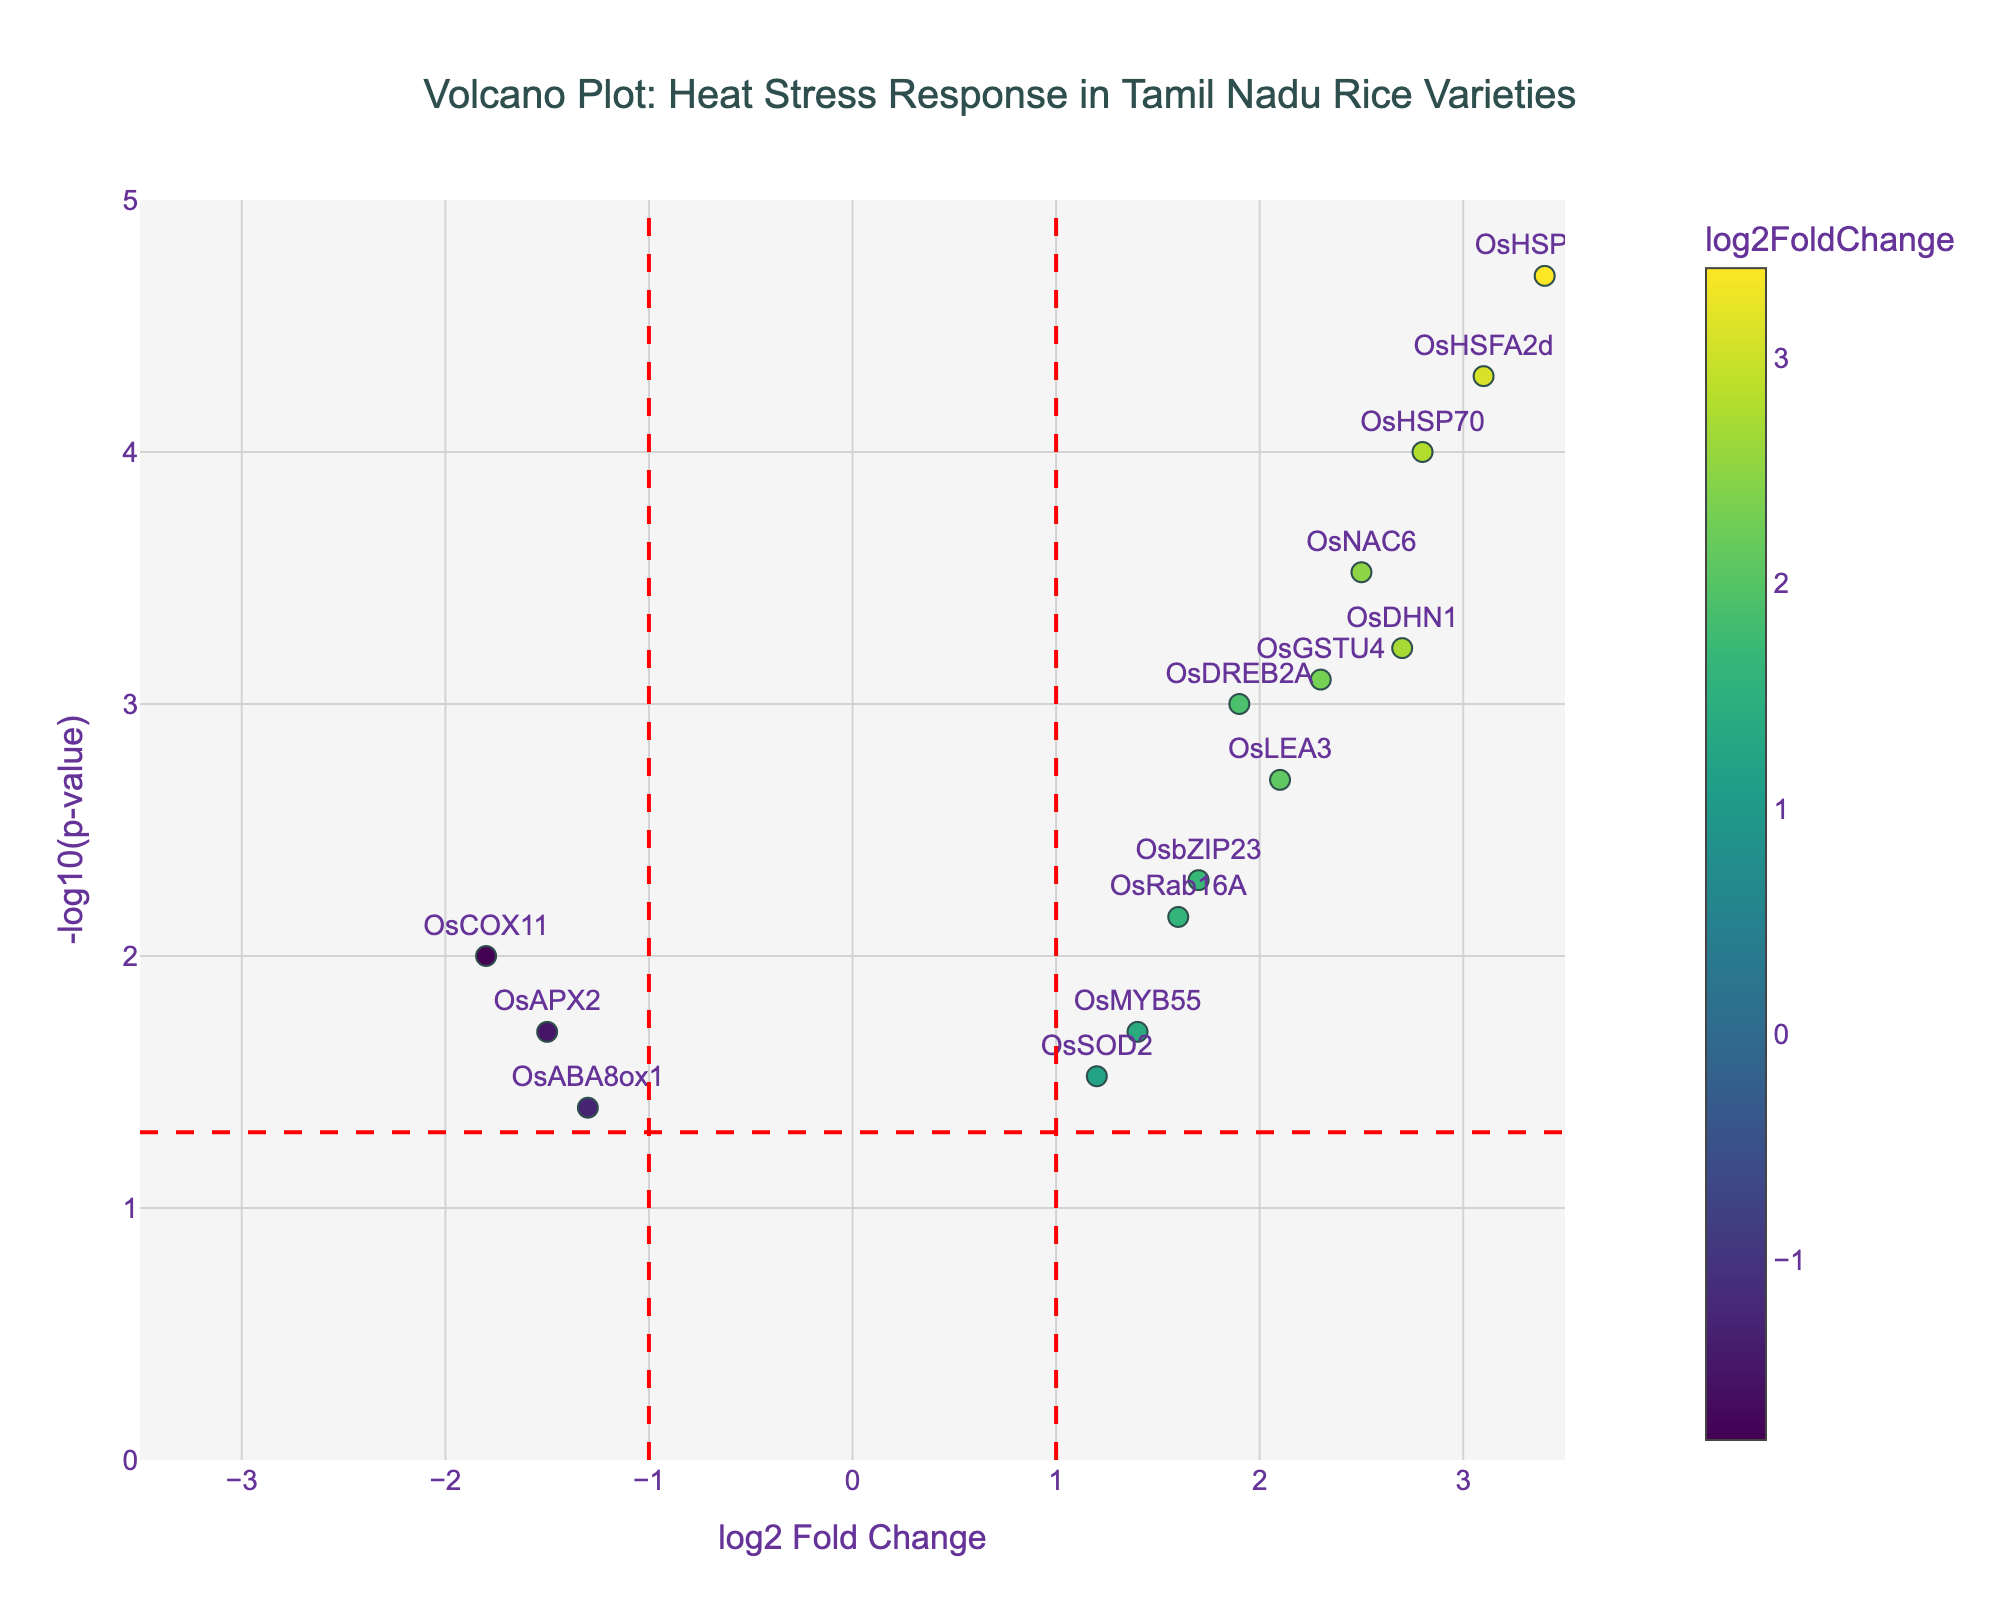What's the title of the figure? The title is generally placed at the top center of the figure. It provides an idea of what the figure represents. In this case, it reads "Volcano Plot: Heat Stress Response in Tamil Nadu Rice Varieties".
Answer: Volcano Plot: Heat Stress Response in Tamil Nadu Rice Varieties What does the x-axis represent? The x-axis displays "log2 Fold Change" which indicates the logarithm base 2 of the fold change in gene expression under heat stress compared to control conditions.
Answer: log2 Fold Change What does the y-axis represent? The y-axis represents "-log10(p-value)", which is the negative base 10 logarithm of the p-value, indicating the significance of the change in gene expression.
Answer: -log10(p-value) How many genes have a significant p-value of less than 0.05? A red horizontal line marks the threshold for p-value < 0.05 (-log10(0.05)). Any point above this line represents a significant p-value. Count the number of data points above this line.
Answer: 11 Which gene has the highest log2 fold change? Identify the gene labeled at the farthest right along the x-axis, which signifies the highest log2 fold change. In the plot, this is the gene towards the rightmost point.
Answer: OsHSP101 How many genes have a log2 fold change greater than 2? Check the x-axis for data points with log2 fold change > 2; count the corresponding points. These will be to the right of the vertical line at x=2.
Answer: 5 Which gene has the lowest p-value? The p-value is inversely related to -log10(p-value). Therefore, the gene with the highest -log10(p-value) has the lowest p-value. Identify this point.
Answer: OsHSP101 Which gene shows a negative log2 fold change and is significant (p-value < 0.05)? Look for genes on the left side of the y-axis (negative log2 fold change) above the red horizontal line (p-value < 0.05). There are few, and one of them must be identified.
Answer: OsCOX11 What is the -log10(p-value) for OsDREB2A? Locate the OsDREB2A label in the plot, then check its y-value position which is the -log10(p-value) value.
Answer: 3.0 Which gene has a log2 fold change between 1 and 2 with a p-value < 0.01? Find points between 1 and 2 on the x-axis and above the corresponding -log10(0.01) y-axis value. Identify the gene labels for these points.
Answer: OsABF1 